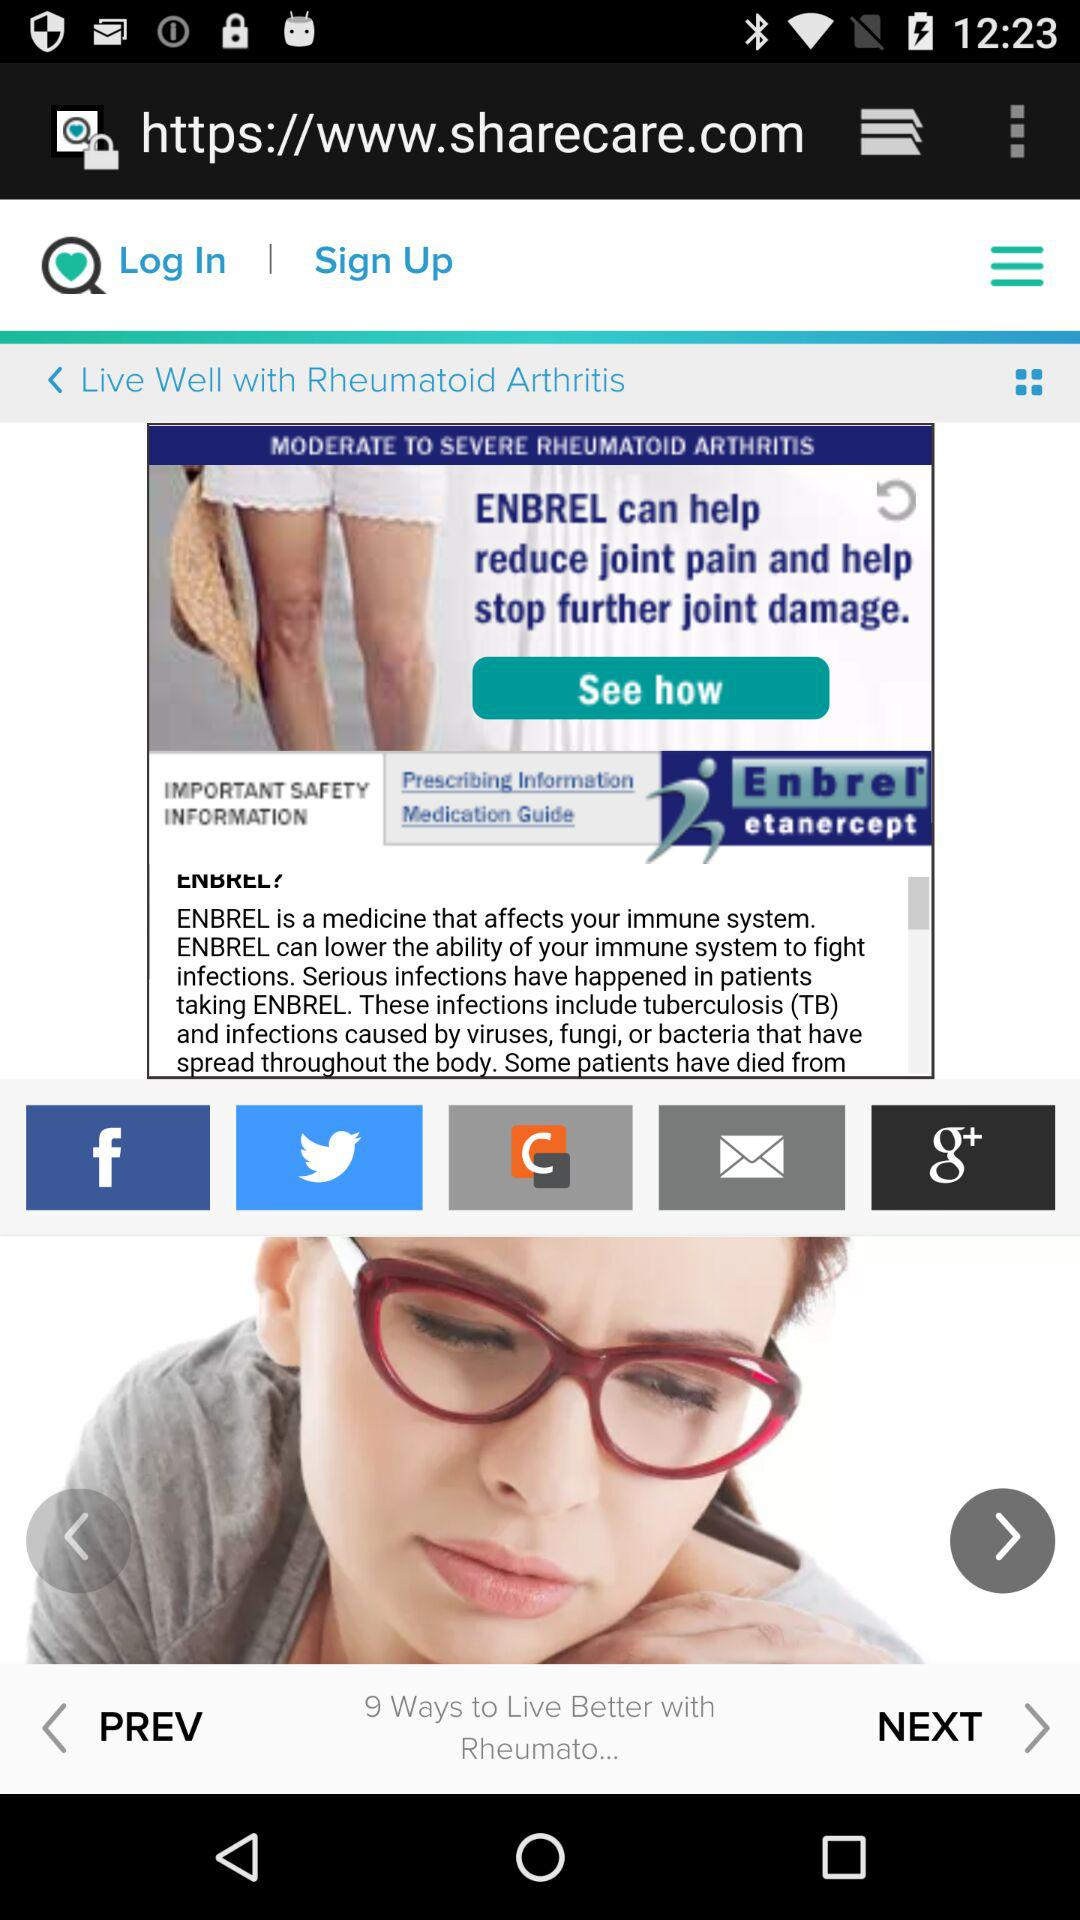How many ways can one live better with rheumatoid? There are nine ways to live better with rheumatoid. 